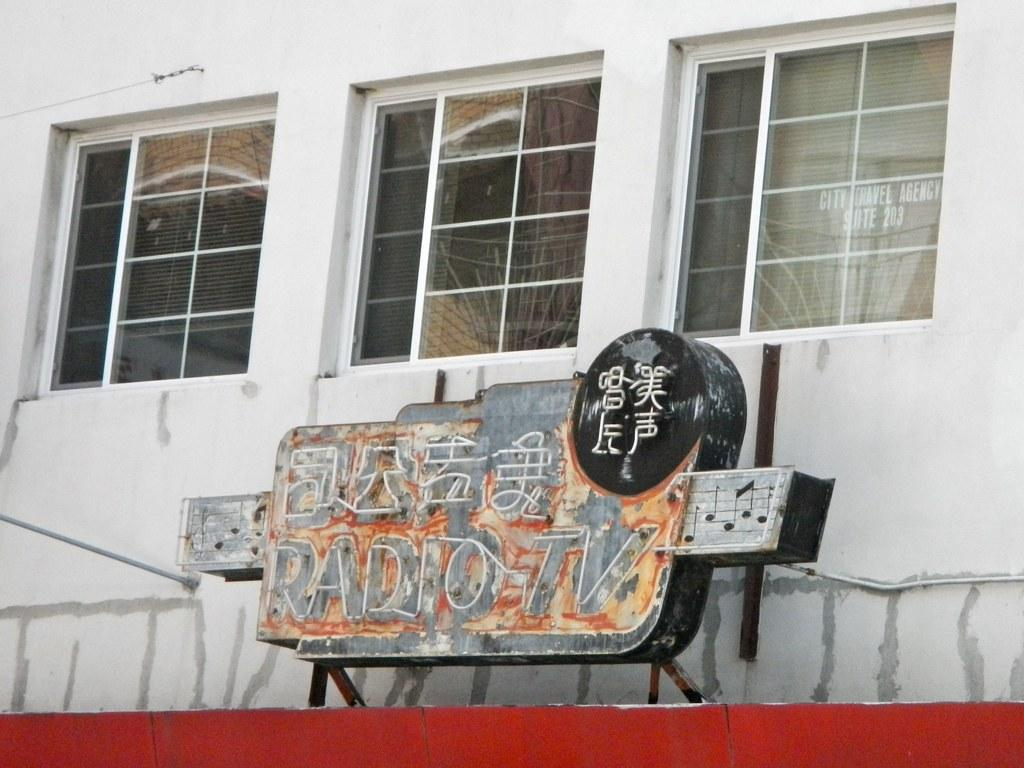What is the main object in the image? There is a board in the image. What can be seen behind the board? There is a wall in the image. Are there any openings in the wall? Yes, there are glass windows in the image. Can you see anyone smiling near the seashore in the image? There is no seashore or smiling person present in the image. 